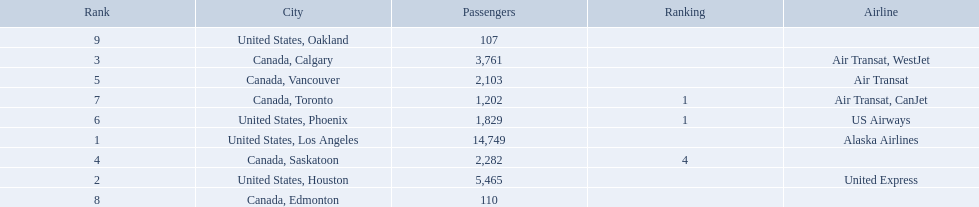Which cities had less than 2,000 passengers? United States, Phoenix, Canada, Toronto, Canada, Edmonton, United States, Oakland. Of these cities, which had fewer than 1,000 passengers? Canada, Edmonton, United States, Oakland. Of the cities in the previous answer, which one had only 107 passengers? United States, Oakland. 